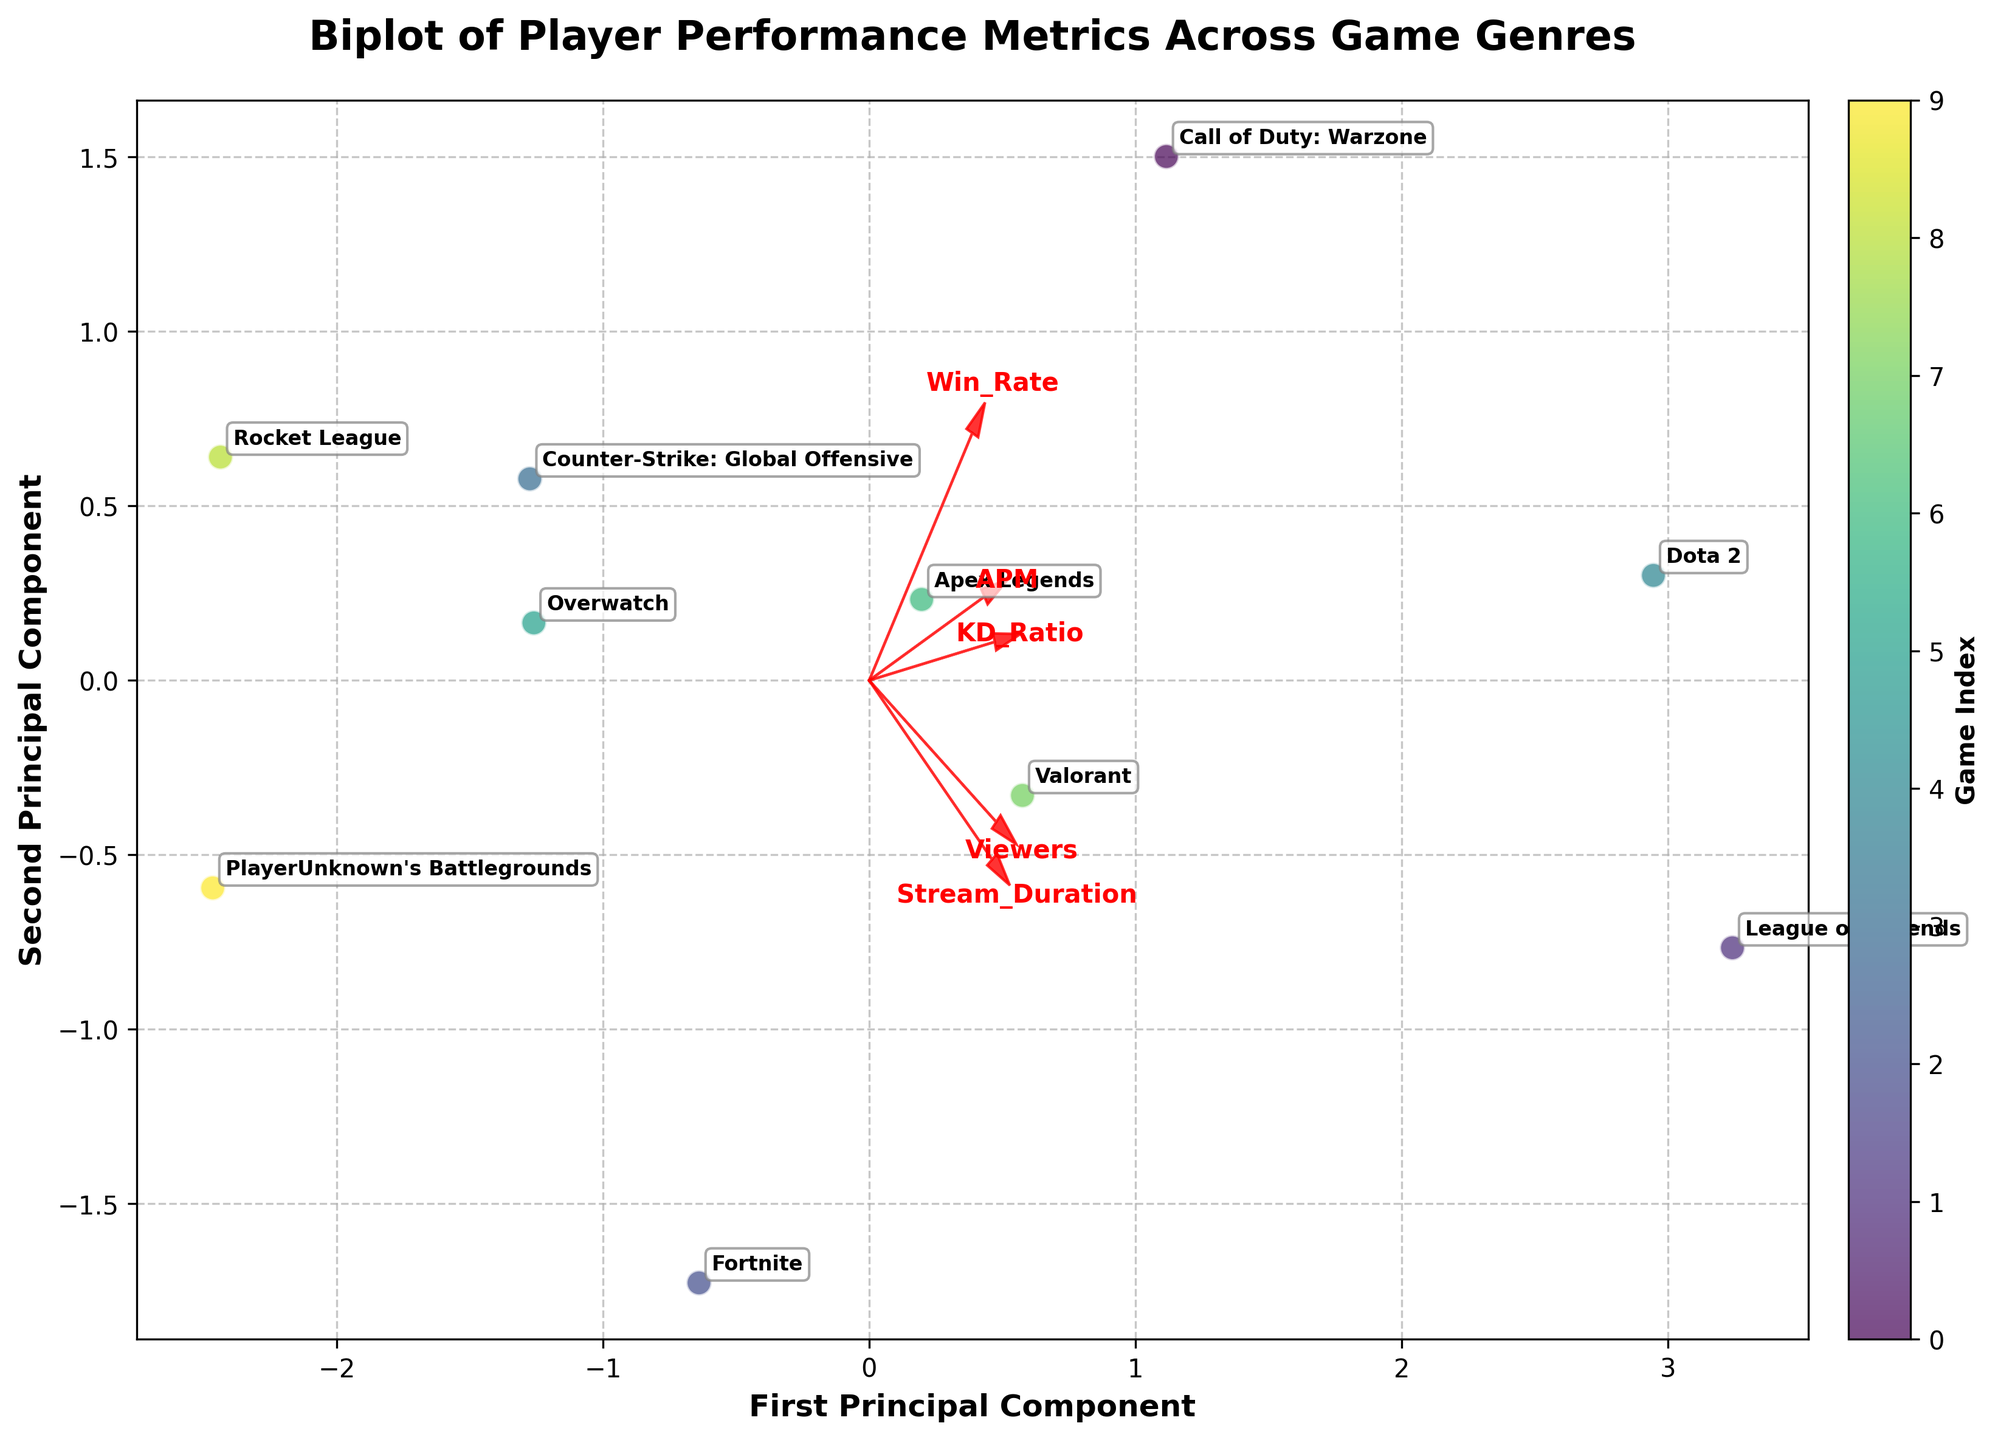What's the title of the plot? The title is located at the top of the figure and usually provides a summary of what the plot represents.
Answer: Biplot of Player Performance Metrics Across Game Genres What does the horizontal axis represent? The horizontal axis is labeled, indicating it represents the First Principal Component.
Answer: First Principal Component Which game genre is associated with the highest principal component values? By observing the annotated labels and their positions on the plot, the game genre with the highest values along the principal components can be determined.
Answer: League of Legends Between 'League of Legends' and 'Dota 2', which game genre is positioned closer to the origin? To find the game closer to the origin, look for the labeled points of these two genres and compare their distances from the center (0, 0).
Answer: Dota 2 How many game genres are displayed in the plot? Count the distinct labeled points representing each game genre to determine the total number of game genres.
Answer: 10 Which performance metric has the strongest influence on the second principal component? Observe the direction and length of the arrows; the arrow that points most prominently along the second principal component axis is the answer.
Answer: APM Rank 'KD_Ratio', 'APM', 'Win_Rate', 'Viewers', and 'Stream_Duration' by their influence on the first principal component from highest to lowest. Compare the lengths of the arrows along the first principal component axis to rank their influence.
Answer: KD_Ratio > Viewers > APM > Win_Rate > Stream_Duration Which game genres are clustered closely together in the plot? Identify the clusters of points that are closely packed together on the plot, focusing on their annotated labels.
Answer: Apex Legends, Call of Duty: Warzone, Counter-Strike: Global Offensive Are there any game genres with a low Win Rate and high KD Ratio positioned near each other? Look for the positions of the labeled points and arrows on the plot to find game genres with these particular characteristics.
Answer: Yes, Call of Duty: Warzone and Apex Legends What does the colorbar represent in the plot? The colorbar is typically explained by its label, which indicates what the color gradient signifies.
Answer: Game Index 